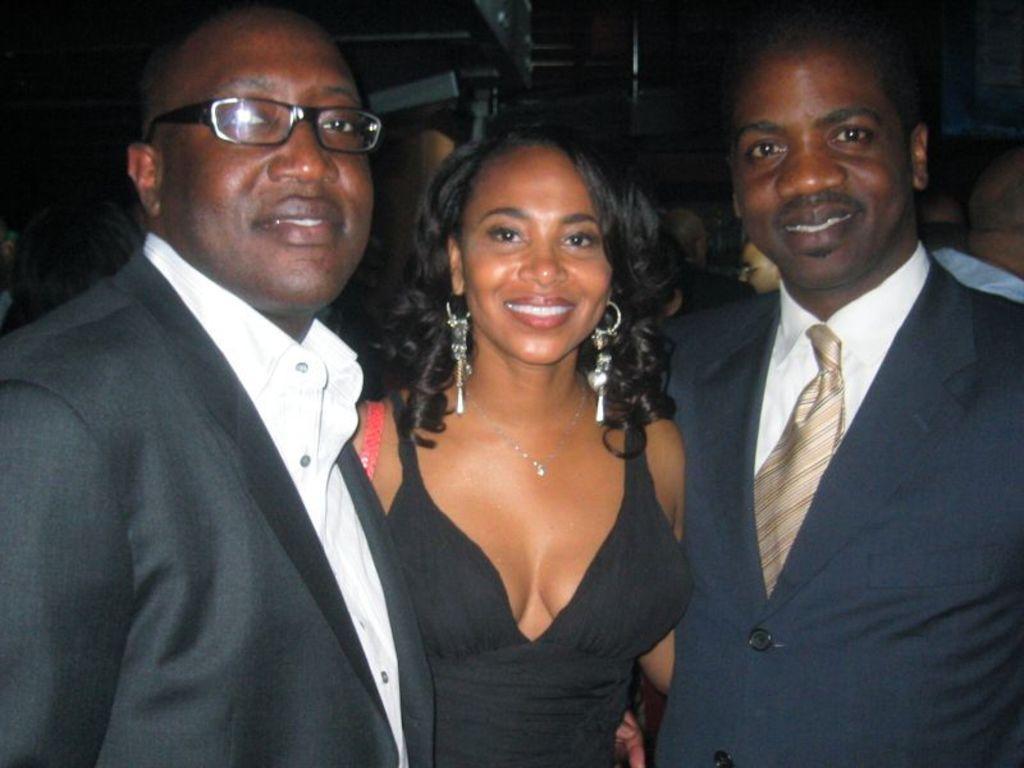Could you give a brief overview of what you see in this image? In this picture we can see two men wore blazers and a woman and they are smiling and in the background we can see some people. 